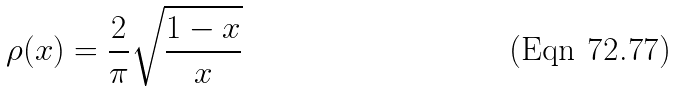<formula> <loc_0><loc_0><loc_500><loc_500>\rho ( x ) = \frac { 2 } { \pi } \sqrt { \frac { 1 - x } { x } }</formula> 